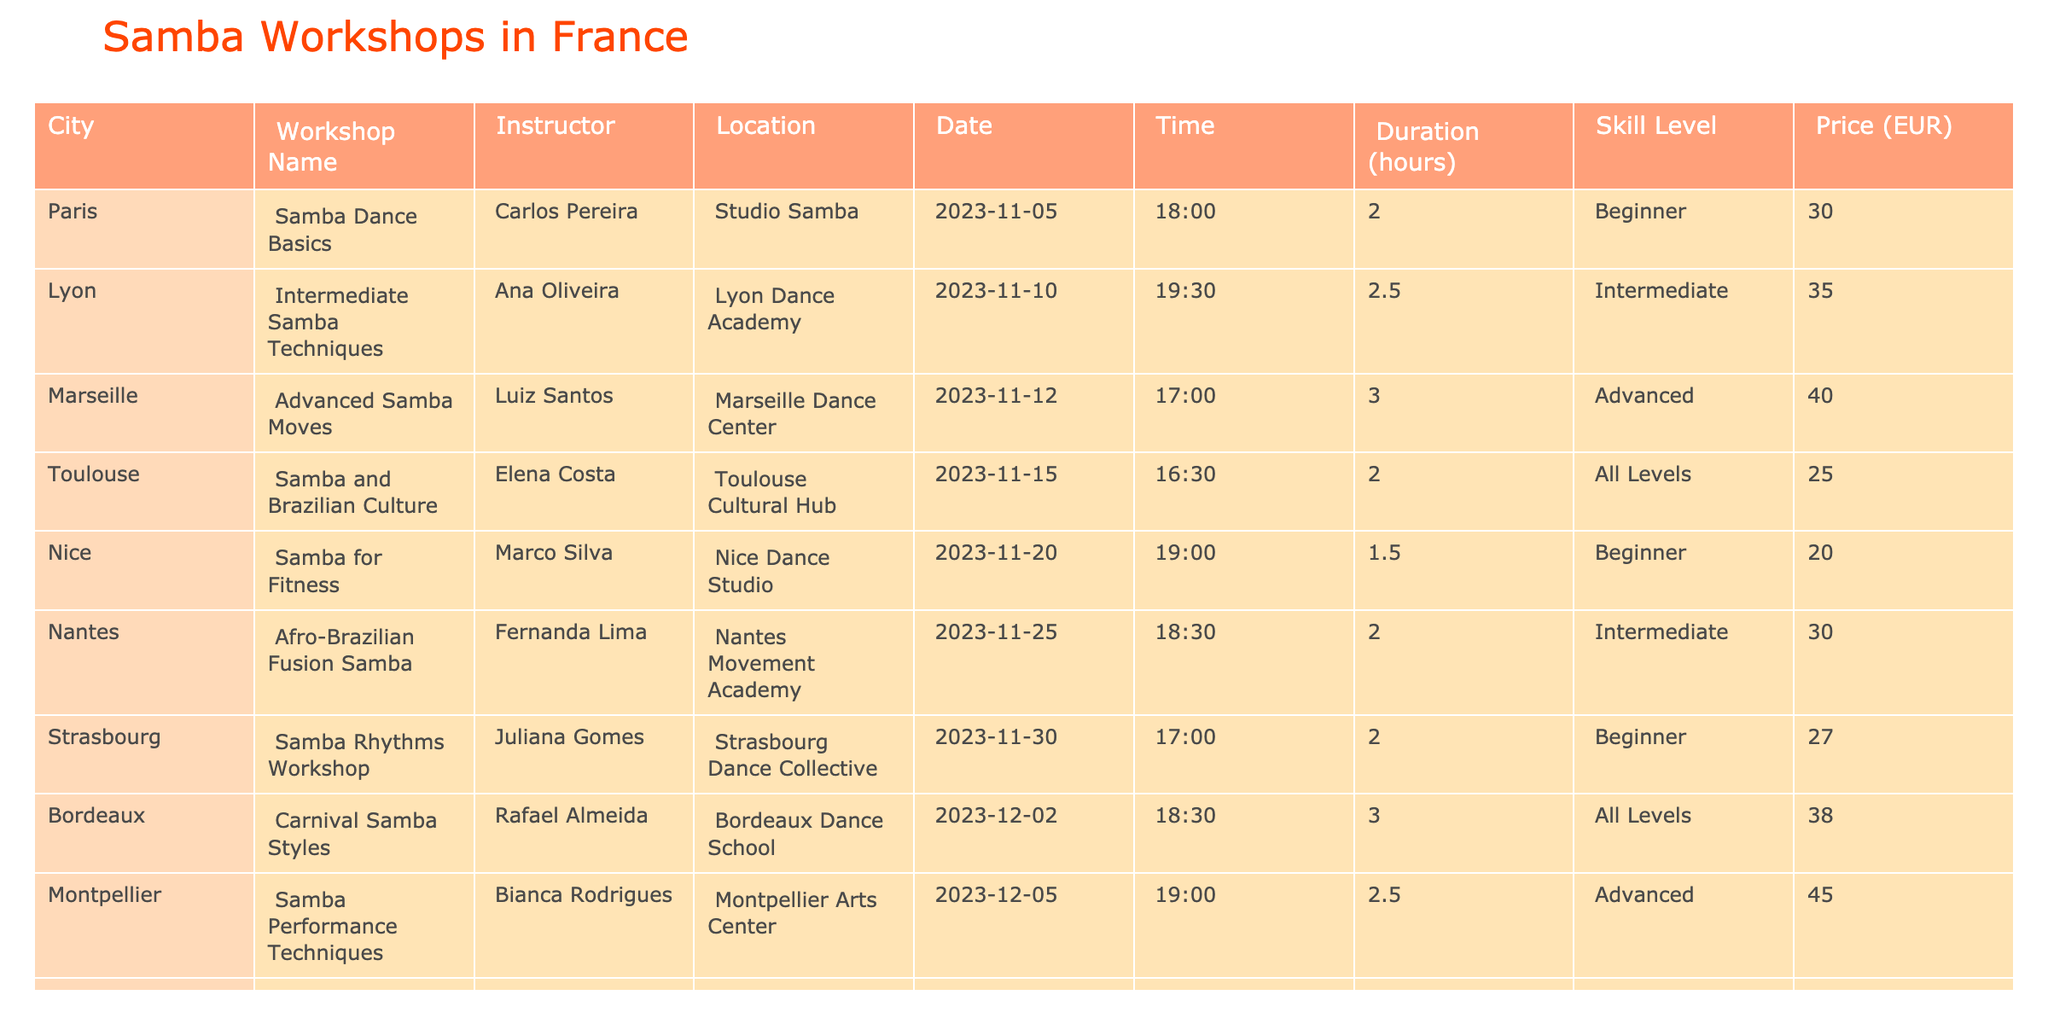What is the price for the "Samba Dance Basics" workshop? The price for the "Samba Dance Basics" workshop led by Carlos Pereira in Paris is listed in the table under the Price column. It shows that the price is 30 EUR.
Answer: 30 EUR How many hours does the "Advanced Samba Moves" workshop last? The duration for the "Advanced Samba Moves" workshop, which takes place in Marseille, is mentioned in the Duration column, and it states that it lasts 3 hours.
Answer: 3 hours Is there a samba workshop in Nice aimed at beginners? The table shows the "Samba for Fitness" workshop in Nice, and it indicates that this workshop is for beginners, confirming that there is a samba workshop for beginners in Nice.
Answer: Yes Which workshop has the highest duration, and what is that duration? By examining the Duration column, the "Advanced Samba Moves" workshop has a duration of 3 hours, which is the highest when compared to all the other workshops listed in the table.
Answer: 3 hours What is the average price of samba workshops for intermediate skill levels? The workshops listed as intermediate skill levels are "Intermediate Samba Techniques" at 35 EUR and "Afro-Brazilian Fusion Samba" at 30 EUR. The total price is 35 + 30 = 65 EUR. Then, dividing by 2 gives an average price of 65 / 2 = 32.5 EUR.
Answer: 32.5 EUR How many workshops are scheduled for November 2023? There are five workshops listed with dates in November: "Samba Dance Basics" in Paris, "Intermediate Samba Techniques" in Lyon, "Advanced Samba Moves" in Marseille, "Samba and Brazilian Culture" in Toulouse, and "Afro-Brazilian Fusion Samba" in Nantes. Therefore, the total count is 5 workshops.
Answer: 5 What is the total price for all workshops scheduled in December? The workshops scheduled for December from the table are "Carnival Samba Styles" at 38 EUR, "Samba Performance Techniques" at 45 EUR, and "Family Samba Dance Class" at 15 EUR. Adding these amounts gives 38 + 45 + 15 = 98 EUR, which is the total price for all December workshops.
Answer: 98 EUR Is there a workshop in Lyon, and if so, what is its skill level? The table indicates that there is indeed a workshop in Lyon called "Intermediate Samba Techniques," and it specifies that the skill level for this workshop is intermediate.
Answer: Yes, Intermediate What is the skill level required for the "Samba Rhythms Workshop"? The "Samba Rhythms Workshop" in Strasbourg notes the skill level in the table, which is listed as beginner.
Answer: Beginner 